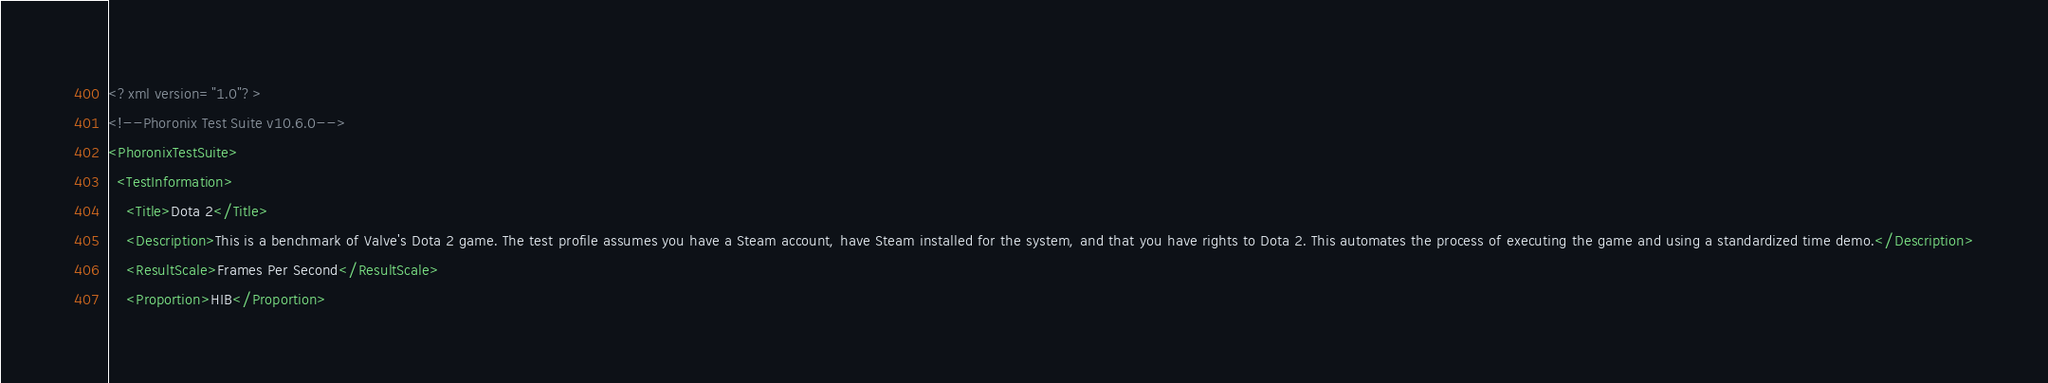Convert code to text. <code><loc_0><loc_0><loc_500><loc_500><_XML_><?xml version="1.0"?>
<!--Phoronix Test Suite v10.6.0-->
<PhoronixTestSuite>
  <TestInformation>
    <Title>Dota 2</Title>
    <Description>This is a benchmark of Valve's Dota 2 game. The test profile assumes you have a Steam account, have Steam installed for the system, and that you have rights to Dota 2. This automates the process of executing the game and using a standardized time demo.</Description>
    <ResultScale>Frames Per Second</ResultScale>
    <Proportion>HIB</Proportion></code> 